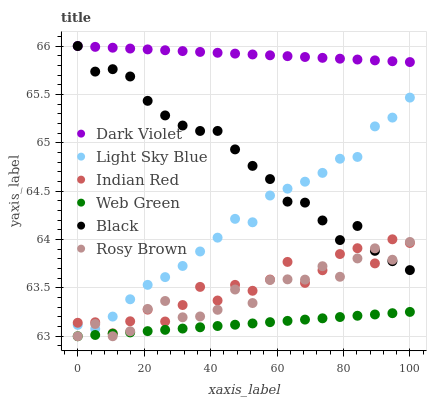Does Web Green have the minimum area under the curve?
Answer yes or no. Yes. Does Dark Violet have the maximum area under the curve?
Answer yes or no. Yes. Does Light Sky Blue have the minimum area under the curve?
Answer yes or no. No. Does Light Sky Blue have the maximum area under the curve?
Answer yes or no. No. Is Web Green the smoothest?
Answer yes or no. Yes. Is Indian Red the roughest?
Answer yes or no. Yes. Is Light Sky Blue the smoothest?
Answer yes or no. No. Is Light Sky Blue the roughest?
Answer yes or no. No. Does Rosy Brown have the lowest value?
Answer yes or no. Yes. Does Light Sky Blue have the lowest value?
Answer yes or no. No. Does Dark Violet have the highest value?
Answer yes or no. Yes. Does Light Sky Blue have the highest value?
Answer yes or no. No. Is Web Green less than Black?
Answer yes or no. Yes. Is Black greater than Web Green?
Answer yes or no. Yes. Does Indian Red intersect Black?
Answer yes or no. Yes. Is Indian Red less than Black?
Answer yes or no. No. Is Indian Red greater than Black?
Answer yes or no. No. Does Web Green intersect Black?
Answer yes or no. No. 